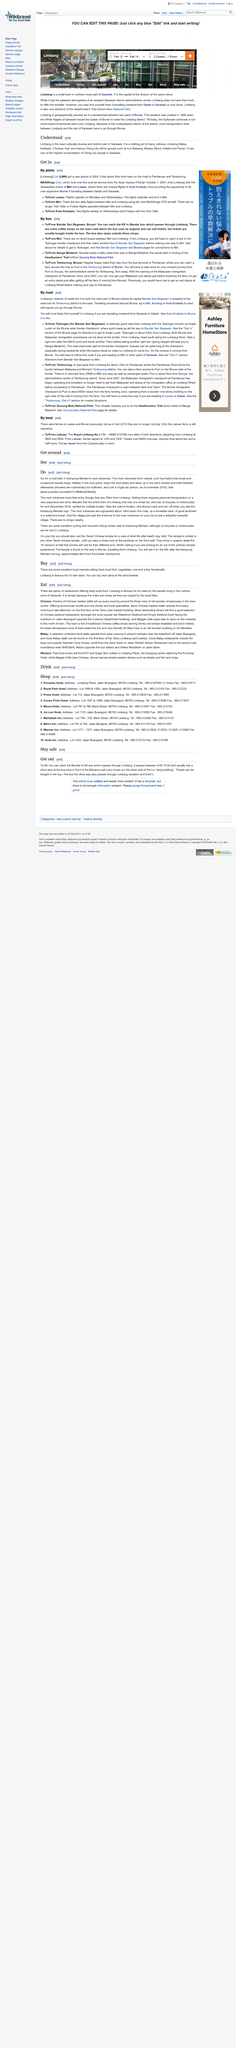Point out several critical features in this image. Limbang acquired a new airport in 2004. Limbang is connected to the Sarawakian towns of Mirir and Lawas by MASWings, which assumed the rural air service in October 2007. Limbang is the most culturally and diversely rich region in Sarawak. 